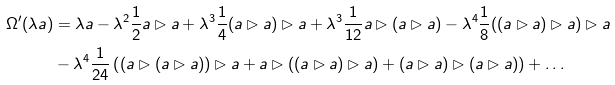Convert formula to latex. <formula><loc_0><loc_0><loc_500><loc_500>\Omega ^ { \prime } ( \lambda a ) & = \lambda a - \lambda ^ { 2 } \frac { 1 } { 2 } a \rhd a + \lambda ^ { 3 } \frac { 1 } { 4 } ( a \rhd a ) \rhd a + \lambda ^ { 3 } \frac { 1 } { 1 2 } a \rhd ( a \rhd a ) - \lambda ^ { 4 } \frac { 1 } { 8 } ( ( a \rhd a ) \rhd a ) \rhd a \\ & - \lambda ^ { 4 } \frac { 1 } { 2 4 } \left ( ( a \rhd ( a \rhd a ) ) \rhd a + a \rhd ( ( a \rhd a ) \rhd a ) + ( a \rhd a ) \rhd ( a \rhd a ) \right ) + \dots</formula> 